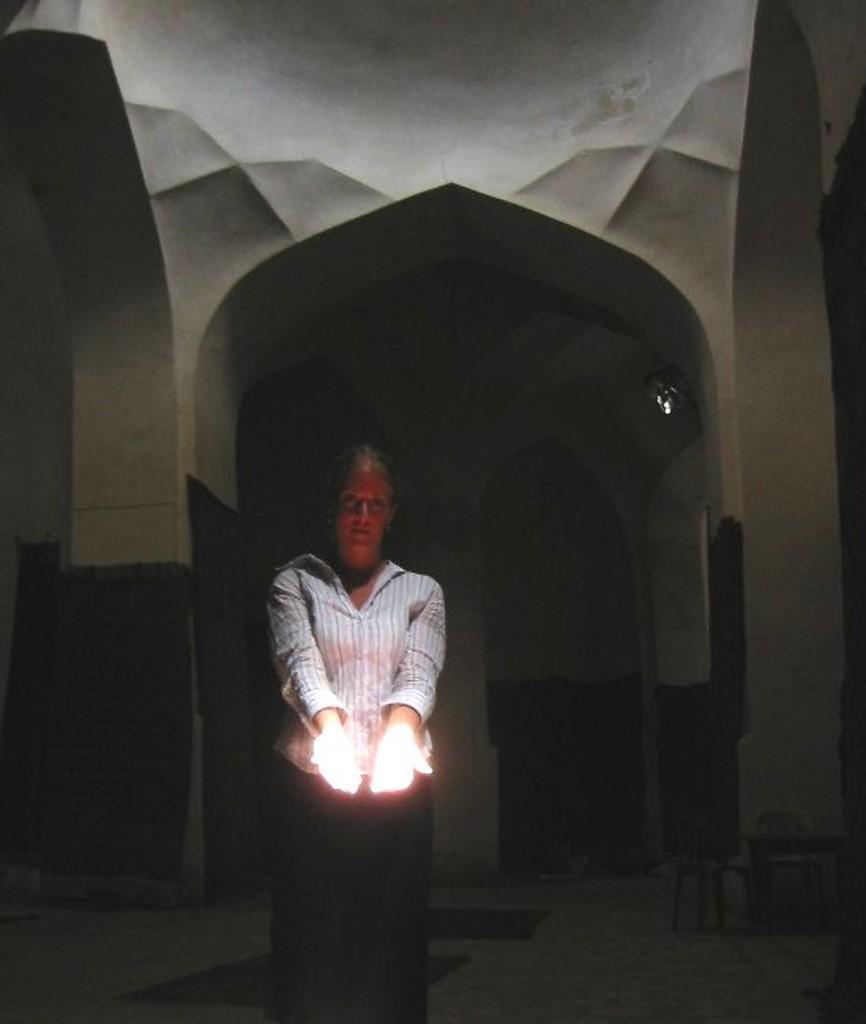Please provide a concise description of this image. In this image, we can see a person. We can see some arches and the roof with an object. We can also see the ground with some objects. 